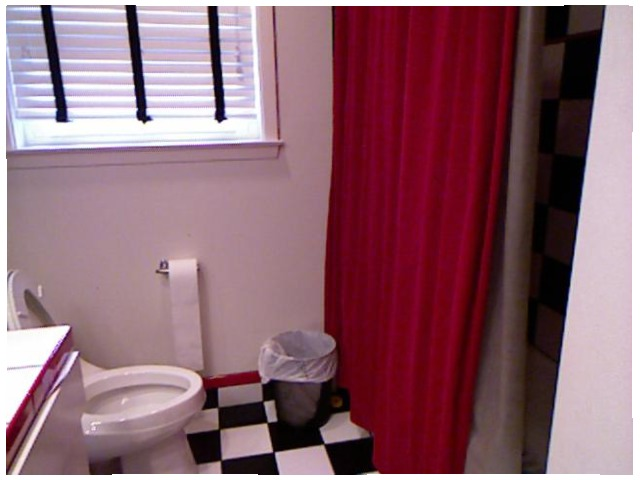<image>
Can you confirm if the window is on the wall? Yes. Looking at the image, I can see the window is positioned on top of the wall, with the wall providing support. Is the bag in the can? Yes. The bag is contained within or inside the can, showing a containment relationship. Is there a toilet next to the waste basket? Yes. The toilet is positioned adjacent to the waste basket, located nearby in the same general area. 